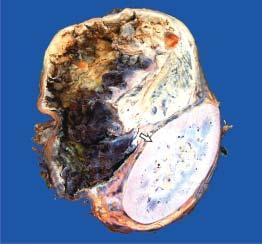what shows compressed kidney at the lower end while the upper end shows a large spherical tumour separate from the kidney?
Answer the question using a single word or phrase. Specimen 